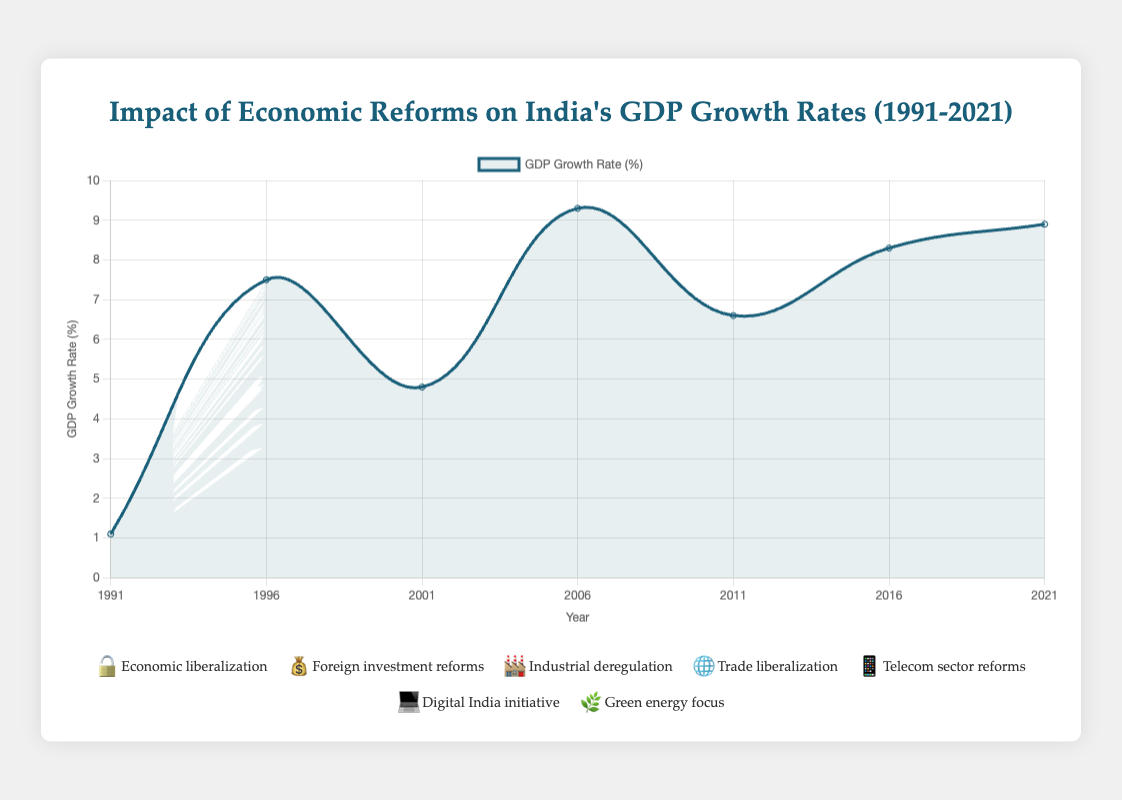What is the title of the chart? The title of the chart is written at the top and reads "Impact of Economic Reforms on India's GDP Growth Rates (1991-2021)."
Answer: Impact of Economic Reforms on India's GDP Growth Rates (1991-2021) What was India's GDP growth rate in the year 1996? The GDP growth rate for 1996 is directly plotted on the chart as a point labeled with the corresponding year. According to the chart, the growth rate in 1996 is 7.5%.
Answer: 7.5% Which emoji represents the "Telecom sector reforms" policy, and in which year was it implemented? The legend below the chart lists the policies along with their corresponding emojis. The "Telecom sector reforms" policy is represented by the 📱 emoji and was implemented in 2011, according to the data.
Answer: 📱, 2011 How did the GDP growth rate change from 1991 to 2001? To find the change, locate the GDP growth rates for 1991 and 2001 on the chart. In 1991, the growth rate was 1.1%, and in 2001, it was 4.8%. Subtract 1.1 from 4.8 to get the change.
Answer: Increased by 3.7% Between which two years was the largest decrease in GDP growth rate observed? Examine the chart to identify the segments where the GDP growth rate decreased. The most significant drop is between 2006 (9.3%) and 2011 (6.6%), a decrease of 2.7 percentage points.
Answer: 2006 and 2011 What was Dr. Manmohan Singh's role in 1991 when the GDP growth rate was 1.1%? Hovering over the point for 1991 in the chart, the tooltip data specifies that Dr. Manmohan Singh's role in 1991 was Finance Minister.
Answer: Finance Minister Compare the GDP growth rates in 2006 and 2021. Which year had a higher rate? Look at the chart points for 2006 and 2021. The GDP growth rate in 2006 was 9.3%, and in 2021 it was 8.9%. Therefore, 2006 had a higher GDP growth rate than 2021.
Answer: 2006 How many key policies are represented by emojis in the chart? Count the number of unique policy emojis listed in the legend below the chart. There are seven key policies represented by emojis in the chart.
Answer: 7 Was the GDP growth rate higher in 2016 or 2021? Refer to the chart points for 2016 and 2021. The GDP growth rate in 2016 was 8.3%, whereas in 2021 it was 8.9%. Hence, the rate was higher in 2021.
Answer: 2021 